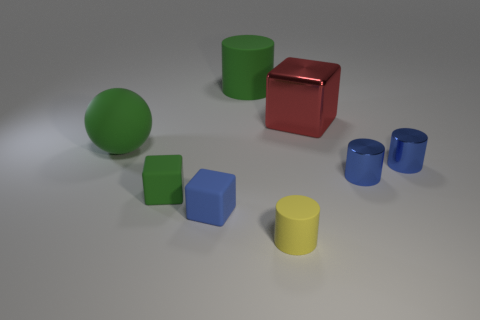What materials do the objects in the scene seem to be made of? The objects in the image appear to be rendered with a matte finish, suggesting that they could be made of materials such as plastic or painted wood. The dull sheen indicates they are non-reflective, which is typical for matte surfaces. 